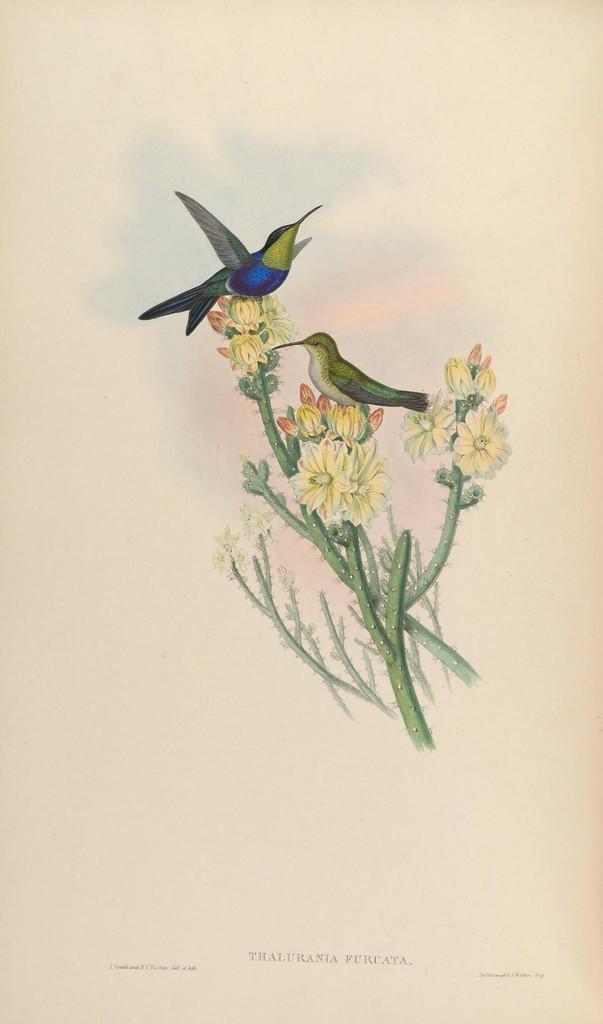How would you summarize this image in a sentence or two? Here in this picture we can see a painting of flower plants and birds present over there. 